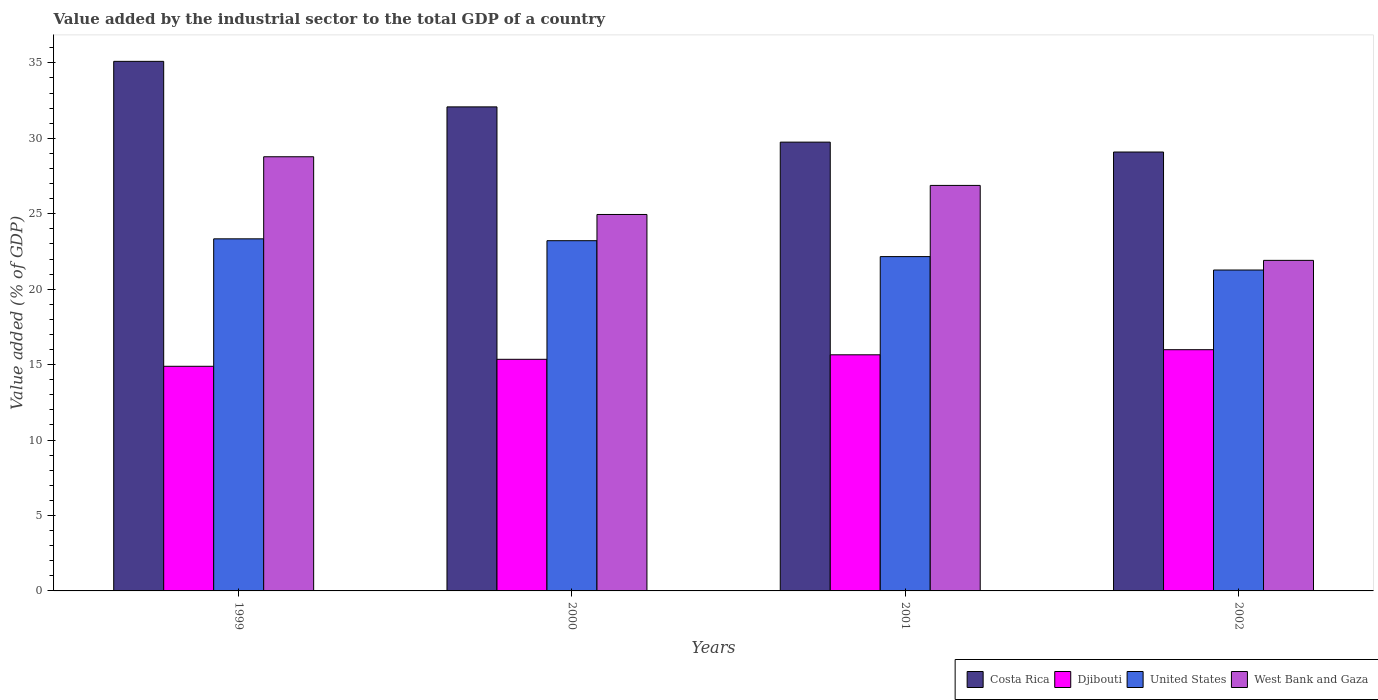How many different coloured bars are there?
Make the answer very short. 4. How many groups of bars are there?
Provide a succinct answer. 4. How many bars are there on the 2nd tick from the right?
Keep it short and to the point. 4. What is the label of the 4th group of bars from the left?
Your response must be concise. 2002. What is the value added by the industrial sector to the total GDP in West Bank and Gaza in 2001?
Your answer should be compact. 26.88. Across all years, what is the maximum value added by the industrial sector to the total GDP in Costa Rica?
Keep it short and to the point. 35.1. Across all years, what is the minimum value added by the industrial sector to the total GDP in West Bank and Gaza?
Make the answer very short. 21.91. What is the total value added by the industrial sector to the total GDP in United States in the graph?
Make the answer very short. 89.98. What is the difference between the value added by the industrial sector to the total GDP in Costa Rica in 1999 and that in 2001?
Provide a short and direct response. 5.35. What is the difference between the value added by the industrial sector to the total GDP in United States in 2000 and the value added by the industrial sector to the total GDP in West Bank and Gaza in 2001?
Your answer should be compact. -3.66. What is the average value added by the industrial sector to the total GDP in West Bank and Gaza per year?
Make the answer very short. 25.63. In the year 1999, what is the difference between the value added by the industrial sector to the total GDP in Djibouti and value added by the industrial sector to the total GDP in Costa Rica?
Give a very brief answer. -20.21. What is the ratio of the value added by the industrial sector to the total GDP in Djibouti in 1999 to that in 2000?
Offer a terse response. 0.97. What is the difference between the highest and the second highest value added by the industrial sector to the total GDP in Djibouti?
Your answer should be compact. 0.34. What is the difference between the highest and the lowest value added by the industrial sector to the total GDP in West Bank and Gaza?
Your answer should be compact. 6.87. Is the sum of the value added by the industrial sector to the total GDP in Costa Rica in 2000 and 2002 greater than the maximum value added by the industrial sector to the total GDP in West Bank and Gaza across all years?
Offer a very short reply. Yes. How many bars are there?
Offer a very short reply. 16. Are all the bars in the graph horizontal?
Provide a succinct answer. No. What is the difference between two consecutive major ticks on the Y-axis?
Make the answer very short. 5. Are the values on the major ticks of Y-axis written in scientific E-notation?
Provide a short and direct response. No. Does the graph contain grids?
Your answer should be very brief. No. Where does the legend appear in the graph?
Offer a terse response. Bottom right. How many legend labels are there?
Your response must be concise. 4. How are the legend labels stacked?
Give a very brief answer. Horizontal. What is the title of the graph?
Your answer should be very brief. Value added by the industrial sector to the total GDP of a country. What is the label or title of the X-axis?
Keep it short and to the point. Years. What is the label or title of the Y-axis?
Your answer should be very brief. Value added (% of GDP). What is the Value added (% of GDP) of Costa Rica in 1999?
Give a very brief answer. 35.1. What is the Value added (% of GDP) of Djibouti in 1999?
Provide a succinct answer. 14.89. What is the Value added (% of GDP) in United States in 1999?
Provide a short and direct response. 23.34. What is the Value added (% of GDP) in West Bank and Gaza in 1999?
Provide a short and direct response. 28.78. What is the Value added (% of GDP) of Costa Rica in 2000?
Provide a succinct answer. 32.08. What is the Value added (% of GDP) in Djibouti in 2000?
Your response must be concise. 15.35. What is the Value added (% of GDP) of United States in 2000?
Offer a very short reply. 23.21. What is the Value added (% of GDP) in West Bank and Gaza in 2000?
Your response must be concise. 24.95. What is the Value added (% of GDP) in Costa Rica in 2001?
Your answer should be very brief. 29.75. What is the Value added (% of GDP) in Djibouti in 2001?
Keep it short and to the point. 15.65. What is the Value added (% of GDP) in United States in 2001?
Give a very brief answer. 22.16. What is the Value added (% of GDP) in West Bank and Gaza in 2001?
Your answer should be compact. 26.88. What is the Value added (% of GDP) of Costa Rica in 2002?
Your answer should be compact. 29.09. What is the Value added (% of GDP) in Djibouti in 2002?
Give a very brief answer. 15.99. What is the Value added (% of GDP) of United States in 2002?
Your answer should be compact. 21.27. What is the Value added (% of GDP) of West Bank and Gaza in 2002?
Ensure brevity in your answer.  21.91. Across all years, what is the maximum Value added (% of GDP) in Costa Rica?
Provide a short and direct response. 35.1. Across all years, what is the maximum Value added (% of GDP) in Djibouti?
Your response must be concise. 15.99. Across all years, what is the maximum Value added (% of GDP) in United States?
Make the answer very short. 23.34. Across all years, what is the maximum Value added (% of GDP) of West Bank and Gaza?
Your answer should be compact. 28.78. Across all years, what is the minimum Value added (% of GDP) in Costa Rica?
Offer a terse response. 29.09. Across all years, what is the minimum Value added (% of GDP) in Djibouti?
Give a very brief answer. 14.89. Across all years, what is the minimum Value added (% of GDP) in United States?
Your response must be concise. 21.27. Across all years, what is the minimum Value added (% of GDP) in West Bank and Gaza?
Your answer should be very brief. 21.91. What is the total Value added (% of GDP) in Costa Rica in the graph?
Your response must be concise. 126.03. What is the total Value added (% of GDP) in Djibouti in the graph?
Your answer should be compact. 61.88. What is the total Value added (% of GDP) in United States in the graph?
Offer a very short reply. 89.98. What is the total Value added (% of GDP) of West Bank and Gaza in the graph?
Ensure brevity in your answer.  102.52. What is the difference between the Value added (% of GDP) in Costa Rica in 1999 and that in 2000?
Offer a very short reply. 3.02. What is the difference between the Value added (% of GDP) in Djibouti in 1999 and that in 2000?
Your answer should be compact. -0.46. What is the difference between the Value added (% of GDP) in United States in 1999 and that in 2000?
Provide a succinct answer. 0.12. What is the difference between the Value added (% of GDP) of West Bank and Gaza in 1999 and that in 2000?
Keep it short and to the point. 3.83. What is the difference between the Value added (% of GDP) in Costa Rica in 1999 and that in 2001?
Make the answer very short. 5.35. What is the difference between the Value added (% of GDP) of Djibouti in 1999 and that in 2001?
Provide a succinct answer. -0.76. What is the difference between the Value added (% of GDP) in United States in 1999 and that in 2001?
Offer a terse response. 1.18. What is the difference between the Value added (% of GDP) of West Bank and Gaza in 1999 and that in 2001?
Your answer should be compact. 1.9. What is the difference between the Value added (% of GDP) in Costa Rica in 1999 and that in 2002?
Provide a succinct answer. 6.01. What is the difference between the Value added (% of GDP) of United States in 1999 and that in 2002?
Keep it short and to the point. 2.07. What is the difference between the Value added (% of GDP) in West Bank and Gaza in 1999 and that in 2002?
Your response must be concise. 6.87. What is the difference between the Value added (% of GDP) of Costa Rica in 2000 and that in 2001?
Your answer should be very brief. 2.34. What is the difference between the Value added (% of GDP) of Djibouti in 2000 and that in 2001?
Offer a very short reply. -0.3. What is the difference between the Value added (% of GDP) in United States in 2000 and that in 2001?
Keep it short and to the point. 1.05. What is the difference between the Value added (% of GDP) in West Bank and Gaza in 2000 and that in 2001?
Your response must be concise. -1.93. What is the difference between the Value added (% of GDP) in Costa Rica in 2000 and that in 2002?
Offer a very short reply. 2.99. What is the difference between the Value added (% of GDP) in Djibouti in 2000 and that in 2002?
Offer a terse response. -0.64. What is the difference between the Value added (% of GDP) of United States in 2000 and that in 2002?
Keep it short and to the point. 1.94. What is the difference between the Value added (% of GDP) in West Bank and Gaza in 2000 and that in 2002?
Offer a terse response. 3.04. What is the difference between the Value added (% of GDP) in Costa Rica in 2001 and that in 2002?
Provide a succinct answer. 0.66. What is the difference between the Value added (% of GDP) in Djibouti in 2001 and that in 2002?
Provide a succinct answer. -0.34. What is the difference between the Value added (% of GDP) of United States in 2001 and that in 2002?
Your answer should be very brief. 0.89. What is the difference between the Value added (% of GDP) of West Bank and Gaza in 2001 and that in 2002?
Keep it short and to the point. 4.97. What is the difference between the Value added (% of GDP) of Costa Rica in 1999 and the Value added (% of GDP) of Djibouti in 2000?
Your answer should be very brief. 19.75. What is the difference between the Value added (% of GDP) of Costa Rica in 1999 and the Value added (% of GDP) of United States in 2000?
Offer a very short reply. 11.89. What is the difference between the Value added (% of GDP) in Costa Rica in 1999 and the Value added (% of GDP) in West Bank and Gaza in 2000?
Provide a short and direct response. 10.15. What is the difference between the Value added (% of GDP) of Djibouti in 1999 and the Value added (% of GDP) of United States in 2000?
Ensure brevity in your answer.  -8.33. What is the difference between the Value added (% of GDP) of Djibouti in 1999 and the Value added (% of GDP) of West Bank and Gaza in 2000?
Your answer should be compact. -10.06. What is the difference between the Value added (% of GDP) of United States in 1999 and the Value added (% of GDP) of West Bank and Gaza in 2000?
Make the answer very short. -1.62. What is the difference between the Value added (% of GDP) in Costa Rica in 1999 and the Value added (% of GDP) in Djibouti in 2001?
Keep it short and to the point. 19.45. What is the difference between the Value added (% of GDP) of Costa Rica in 1999 and the Value added (% of GDP) of United States in 2001?
Provide a short and direct response. 12.94. What is the difference between the Value added (% of GDP) in Costa Rica in 1999 and the Value added (% of GDP) in West Bank and Gaza in 2001?
Provide a succinct answer. 8.22. What is the difference between the Value added (% of GDP) in Djibouti in 1999 and the Value added (% of GDP) in United States in 2001?
Ensure brevity in your answer.  -7.27. What is the difference between the Value added (% of GDP) in Djibouti in 1999 and the Value added (% of GDP) in West Bank and Gaza in 2001?
Offer a terse response. -11.99. What is the difference between the Value added (% of GDP) of United States in 1999 and the Value added (% of GDP) of West Bank and Gaza in 2001?
Keep it short and to the point. -3.54. What is the difference between the Value added (% of GDP) of Costa Rica in 1999 and the Value added (% of GDP) of Djibouti in 2002?
Offer a very short reply. 19.11. What is the difference between the Value added (% of GDP) of Costa Rica in 1999 and the Value added (% of GDP) of United States in 2002?
Your answer should be very brief. 13.83. What is the difference between the Value added (% of GDP) of Costa Rica in 1999 and the Value added (% of GDP) of West Bank and Gaza in 2002?
Your response must be concise. 13.19. What is the difference between the Value added (% of GDP) in Djibouti in 1999 and the Value added (% of GDP) in United States in 2002?
Make the answer very short. -6.38. What is the difference between the Value added (% of GDP) in Djibouti in 1999 and the Value added (% of GDP) in West Bank and Gaza in 2002?
Ensure brevity in your answer.  -7.02. What is the difference between the Value added (% of GDP) in United States in 1999 and the Value added (% of GDP) in West Bank and Gaza in 2002?
Provide a short and direct response. 1.43. What is the difference between the Value added (% of GDP) of Costa Rica in 2000 and the Value added (% of GDP) of Djibouti in 2001?
Keep it short and to the point. 16.43. What is the difference between the Value added (% of GDP) of Costa Rica in 2000 and the Value added (% of GDP) of United States in 2001?
Give a very brief answer. 9.92. What is the difference between the Value added (% of GDP) in Costa Rica in 2000 and the Value added (% of GDP) in West Bank and Gaza in 2001?
Ensure brevity in your answer.  5.2. What is the difference between the Value added (% of GDP) in Djibouti in 2000 and the Value added (% of GDP) in United States in 2001?
Offer a very short reply. -6.81. What is the difference between the Value added (% of GDP) in Djibouti in 2000 and the Value added (% of GDP) in West Bank and Gaza in 2001?
Offer a terse response. -11.53. What is the difference between the Value added (% of GDP) in United States in 2000 and the Value added (% of GDP) in West Bank and Gaza in 2001?
Give a very brief answer. -3.66. What is the difference between the Value added (% of GDP) in Costa Rica in 2000 and the Value added (% of GDP) in Djibouti in 2002?
Offer a terse response. 16.09. What is the difference between the Value added (% of GDP) of Costa Rica in 2000 and the Value added (% of GDP) of United States in 2002?
Offer a terse response. 10.81. What is the difference between the Value added (% of GDP) of Costa Rica in 2000 and the Value added (% of GDP) of West Bank and Gaza in 2002?
Your answer should be compact. 10.17. What is the difference between the Value added (% of GDP) of Djibouti in 2000 and the Value added (% of GDP) of United States in 2002?
Your response must be concise. -5.92. What is the difference between the Value added (% of GDP) in Djibouti in 2000 and the Value added (% of GDP) in West Bank and Gaza in 2002?
Provide a short and direct response. -6.56. What is the difference between the Value added (% of GDP) in United States in 2000 and the Value added (% of GDP) in West Bank and Gaza in 2002?
Keep it short and to the point. 1.3. What is the difference between the Value added (% of GDP) of Costa Rica in 2001 and the Value added (% of GDP) of Djibouti in 2002?
Your response must be concise. 13.76. What is the difference between the Value added (% of GDP) in Costa Rica in 2001 and the Value added (% of GDP) in United States in 2002?
Your response must be concise. 8.48. What is the difference between the Value added (% of GDP) of Costa Rica in 2001 and the Value added (% of GDP) of West Bank and Gaza in 2002?
Your answer should be compact. 7.84. What is the difference between the Value added (% of GDP) of Djibouti in 2001 and the Value added (% of GDP) of United States in 2002?
Make the answer very short. -5.62. What is the difference between the Value added (% of GDP) of Djibouti in 2001 and the Value added (% of GDP) of West Bank and Gaza in 2002?
Your answer should be very brief. -6.26. What is the difference between the Value added (% of GDP) of United States in 2001 and the Value added (% of GDP) of West Bank and Gaza in 2002?
Give a very brief answer. 0.25. What is the average Value added (% of GDP) in Costa Rica per year?
Give a very brief answer. 31.51. What is the average Value added (% of GDP) in Djibouti per year?
Offer a very short reply. 15.47. What is the average Value added (% of GDP) in United States per year?
Keep it short and to the point. 22.5. What is the average Value added (% of GDP) in West Bank and Gaza per year?
Give a very brief answer. 25.63. In the year 1999, what is the difference between the Value added (% of GDP) in Costa Rica and Value added (% of GDP) in Djibouti?
Offer a terse response. 20.21. In the year 1999, what is the difference between the Value added (% of GDP) in Costa Rica and Value added (% of GDP) in United States?
Give a very brief answer. 11.76. In the year 1999, what is the difference between the Value added (% of GDP) of Costa Rica and Value added (% of GDP) of West Bank and Gaza?
Offer a terse response. 6.32. In the year 1999, what is the difference between the Value added (% of GDP) in Djibouti and Value added (% of GDP) in United States?
Your answer should be compact. -8.45. In the year 1999, what is the difference between the Value added (% of GDP) in Djibouti and Value added (% of GDP) in West Bank and Gaza?
Your answer should be very brief. -13.89. In the year 1999, what is the difference between the Value added (% of GDP) of United States and Value added (% of GDP) of West Bank and Gaza?
Provide a succinct answer. -5.44. In the year 2000, what is the difference between the Value added (% of GDP) of Costa Rica and Value added (% of GDP) of Djibouti?
Give a very brief answer. 16.73. In the year 2000, what is the difference between the Value added (% of GDP) of Costa Rica and Value added (% of GDP) of United States?
Your answer should be compact. 8.87. In the year 2000, what is the difference between the Value added (% of GDP) of Costa Rica and Value added (% of GDP) of West Bank and Gaza?
Ensure brevity in your answer.  7.13. In the year 2000, what is the difference between the Value added (% of GDP) in Djibouti and Value added (% of GDP) in United States?
Your response must be concise. -7.86. In the year 2000, what is the difference between the Value added (% of GDP) of Djibouti and Value added (% of GDP) of West Bank and Gaza?
Your response must be concise. -9.6. In the year 2000, what is the difference between the Value added (% of GDP) of United States and Value added (% of GDP) of West Bank and Gaza?
Your response must be concise. -1.74. In the year 2001, what is the difference between the Value added (% of GDP) in Costa Rica and Value added (% of GDP) in Djibouti?
Provide a short and direct response. 14.1. In the year 2001, what is the difference between the Value added (% of GDP) in Costa Rica and Value added (% of GDP) in United States?
Make the answer very short. 7.59. In the year 2001, what is the difference between the Value added (% of GDP) in Costa Rica and Value added (% of GDP) in West Bank and Gaza?
Ensure brevity in your answer.  2.87. In the year 2001, what is the difference between the Value added (% of GDP) of Djibouti and Value added (% of GDP) of United States?
Offer a very short reply. -6.51. In the year 2001, what is the difference between the Value added (% of GDP) of Djibouti and Value added (% of GDP) of West Bank and Gaza?
Your response must be concise. -11.23. In the year 2001, what is the difference between the Value added (% of GDP) of United States and Value added (% of GDP) of West Bank and Gaza?
Provide a short and direct response. -4.72. In the year 2002, what is the difference between the Value added (% of GDP) of Costa Rica and Value added (% of GDP) of Djibouti?
Provide a succinct answer. 13.1. In the year 2002, what is the difference between the Value added (% of GDP) in Costa Rica and Value added (% of GDP) in United States?
Make the answer very short. 7.82. In the year 2002, what is the difference between the Value added (% of GDP) in Costa Rica and Value added (% of GDP) in West Bank and Gaza?
Ensure brevity in your answer.  7.18. In the year 2002, what is the difference between the Value added (% of GDP) of Djibouti and Value added (% of GDP) of United States?
Ensure brevity in your answer.  -5.28. In the year 2002, what is the difference between the Value added (% of GDP) in Djibouti and Value added (% of GDP) in West Bank and Gaza?
Your answer should be very brief. -5.92. In the year 2002, what is the difference between the Value added (% of GDP) of United States and Value added (% of GDP) of West Bank and Gaza?
Provide a short and direct response. -0.64. What is the ratio of the Value added (% of GDP) of Costa Rica in 1999 to that in 2000?
Ensure brevity in your answer.  1.09. What is the ratio of the Value added (% of GDP) in Djibouti in 1999 to that in 2000?
Your answer should be compact. 0.97. What is the ratio of the Value added (% of GDP) of West Bank and Gaza in 1999 to that in 2000?
Your answer should be compact. 1.15. What is the ratio of the Value added (% of GDP) in Costa Rica in 1999 to that in 2001?
Offer a terse response. 1.18. What is the ratio of the Value added (% of GDP) of Djibouti in 1999 to that in 2001?
Keep it short and to the point. 0.95. What is the ratio of the Value added (% of GDP) of United States in 1999 to that in 2001?
Give a very brief answer. 1.05. What is the ratio of the Value added (% of GDP) of West Bank and Gaza in 1999 to that in 2001?
Provide a succinct answer. 1.07. What is the ratio of the Value added (% of GDP) in Costa Rica in 1999 to that in 2002?
Keep it short and to the point. 1.21. What is the ratio of the Value added (% of GDP) of Djibouti in 1999 to that in 2002?
Provide a succinct answer. 0.93. What is the ratio of the Value added (% of GDP) of United States in 1999 to that in 2002?
Your response must be concise. 1.1. What is the ratio of the Value added (% of GDP) of West Bank and Gaza in 1999 to that in 2002?
Your answer should be very brief. 1.31. What is the ratio of the Value added (% of GDP) of Costa Rica in 2000 to that in 2001?
Make the answer very short. 1.08. What is the ratio of the Value added (% of GDP) in Djibouti in 2000 to that in 2001?
Your answer should be very brief. 0.98. What is the ratio of the Value added (% of GDP) of United States in 2000 to that in 2001?
Provide a succinct answer. 1.05. What is the ratio of the Value added (% of GDP) in West Bank and Gaza in 2000 to that in 2001?
Provide a short and direct response. 0.93. What is the ratio of the Value added (% of GDP) in Costa Rica in 2000 to that in 2002?
Offer a very short reply. 1.1. What is the ratio of the Value added (% of GDP) in Djibouti in 2000 to that in 2002?
Your answer should be very brief. 0.96. What is the ratio of the Value added (% of GDP) in United States in 2000 to that in 2002?
Offer a terse response. 1.09. What is the ratio of the Value added (% of GDP) in West Bank and Gaza in 2000 to that in 2002?
Your response must be concise. 1.14. What is the ratio of the Value added (% of GDP) of Costa Rica in 2001 to that in 2002?
Keep it short and to the point. 1.02. What is the ratio of the Value added (% of GDP) of Djibouti in 2001 to that in 2002?
Your response must be concise. 0.98. What is the ratio of the Value added (% of GDP) of United States in 2001 to that in 2002?
Offer a terse response. 1.04. What is the ratio of the Value added (% of GDP) in West Bank and Gaza in 2001 to that in 2002?
Keep it short and to the point. 1.23. What is the difference between the highest and the second highest Value added (% of GDP) of Costa Rica?
Provide a succinct answer. 3.02. What is the difference between the highest and the second highest Value added (% of GDP) in Djibouti?
Your answer should be compact. 0.34. What is the difference between the highest and the second highest Value added (% of GDP) of United States?
Provide a succinct answer. 0.12. What is the difference between the highest and the second highest Value added (% of GDP) in West Bank and Gaza?
Make the answer very short. 1.9. What is the difference between the highest and the lowest Value added (% of GDP) in Costa Rica?
Make the answer very short. 6.01. What is the difference between the highest and the lowest Value added (% of GDP) in United States?
Ensure brevity in your answer.  2.07. What is the difference between the highest and the lowest Value added (% of GDP) in West Bank and Gaza?
Your answer should be compact. 6.87. 